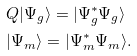<formula> <loc_0><loc_0><loc_500><loc_500>& Q | \Psi _ { g } \rangle = | \Psi _ { g } ^ { * } \Psi _ { g } \rangle \\ & | \Psi _ { m } \rangle = | \Psi _ { m } ^ { * } \Psi _ { m } \rangle .</formula> 